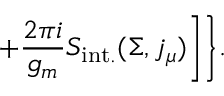<formula> <loc_0><loc_0><loc_500><loc_500>+ \frac { 2 \pi i } { g _ { m } } S _ { i n t . } ( \Sigma , j _ { \mu } ) \Big ] \Big \} .</formula> 